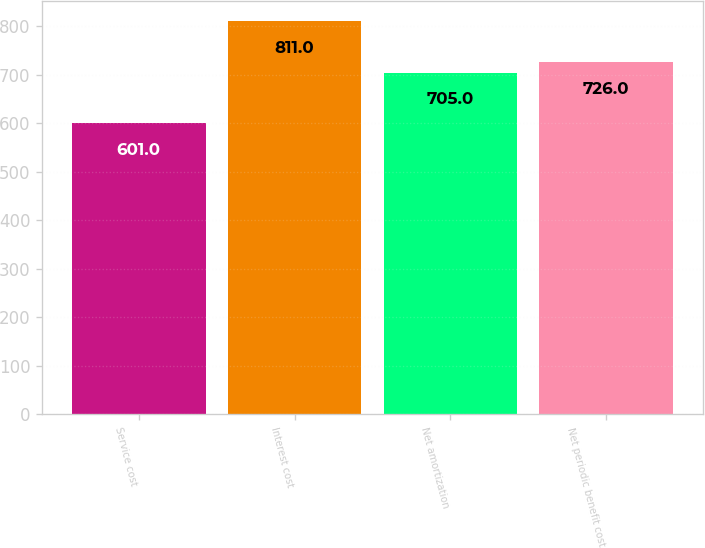<chart> <loc_0><loc_0><loc_500><loc_500><bar_chart><fcel>Service cost<fcel>Interest cost<fcel>Net amortization<fcel>Net periodic benefit cost<nl><fcel>601<fcel>811<fcel>705<fcel>726<nl></chart> 